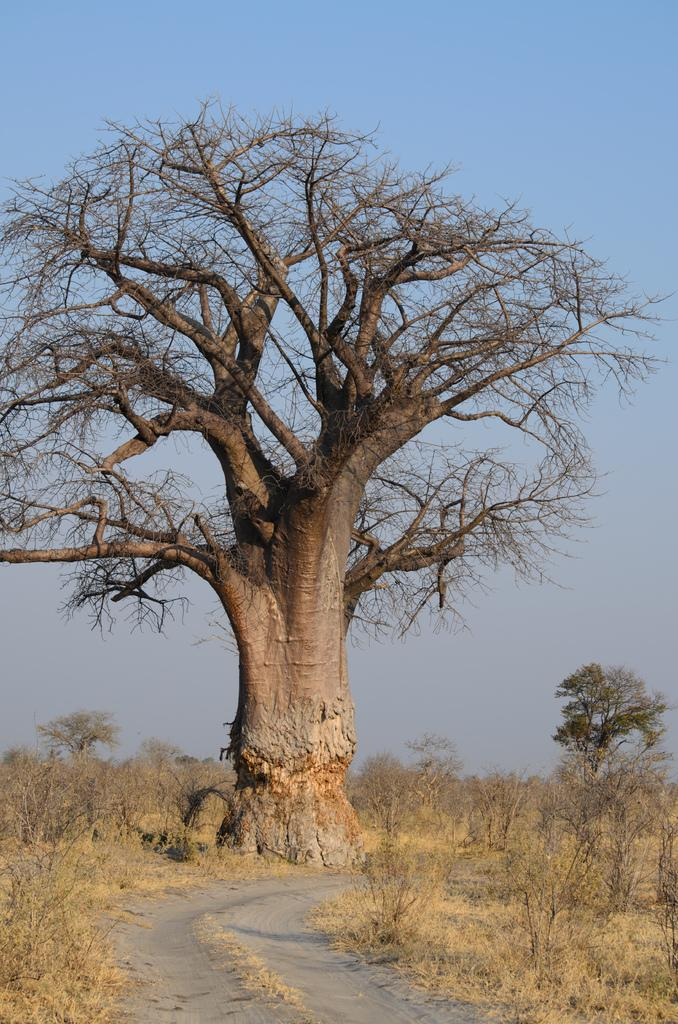What is the main subject in the center of the image? There is a tree in the center of the image. What type of vegetation is at the bottom of the image? There is grass and plants at the bottom of the image. What can be seen at the bottom of the image besides vegetation? There is a walkway at the bottom of the image. What is visible in the background of the image? The sky is visible in the background of the image. Where is the parcel located in the image? There is no parcel present in the image. Can you see a lake in the image? There is no lake present in the image. 